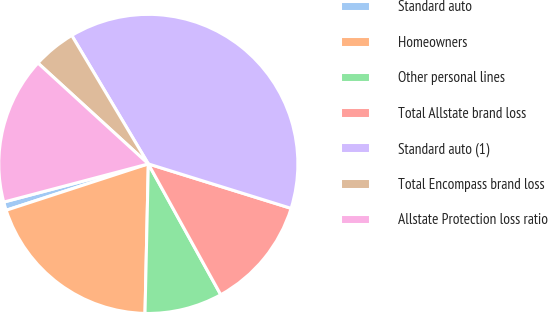Convert chart to OTSL. <chart><loc_0><loc_0><loc_500><loc_500><pie_chart><fcel>Standard auto<fcel>Homeowners<fcel>Other personal lines<fcel>Total Allstate brand loss<fcel>Standard auto (1)<fcel>Total Encompass brand loss<fcel>Allstate Protection loss ratio<nl><fcel>0.91%<fcel>19.63%<fcel>8.4%<fcel>12.15%<fcel>38.36%<fcel>4.66%<fcel>15.89%<nl></chart> 